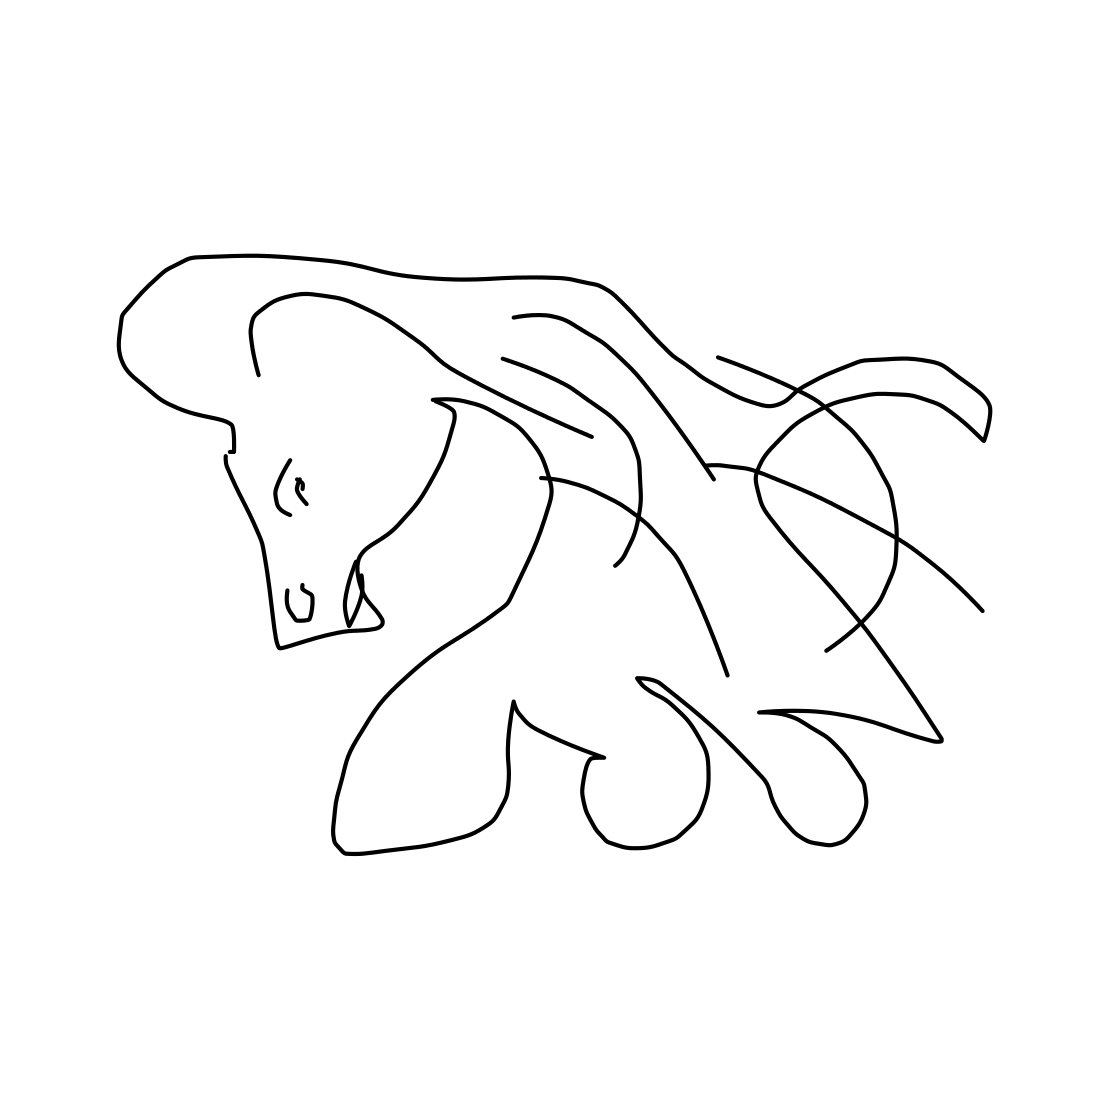What might this type of art suggest about the artist's intention? The artist's use of abstract lines to suggest the form of a horse could indicate a focus on the essence of the subject, stripping away the complexities to leave a strong, impactful impression through simplicity. It suggests an intention to highlight the fluidity and grace of the horse, and to invite viewers to fill in the details with their imagination. Could this artwork be inspired by any particular movements or artists? Yes, the minimalist approach and continuous line technique often echo the influences of modernism and abstract expressionism. The artwork may draw inspiration from artists like Picasso or Matisse, who both explored the boundaries of form and abstraction. 